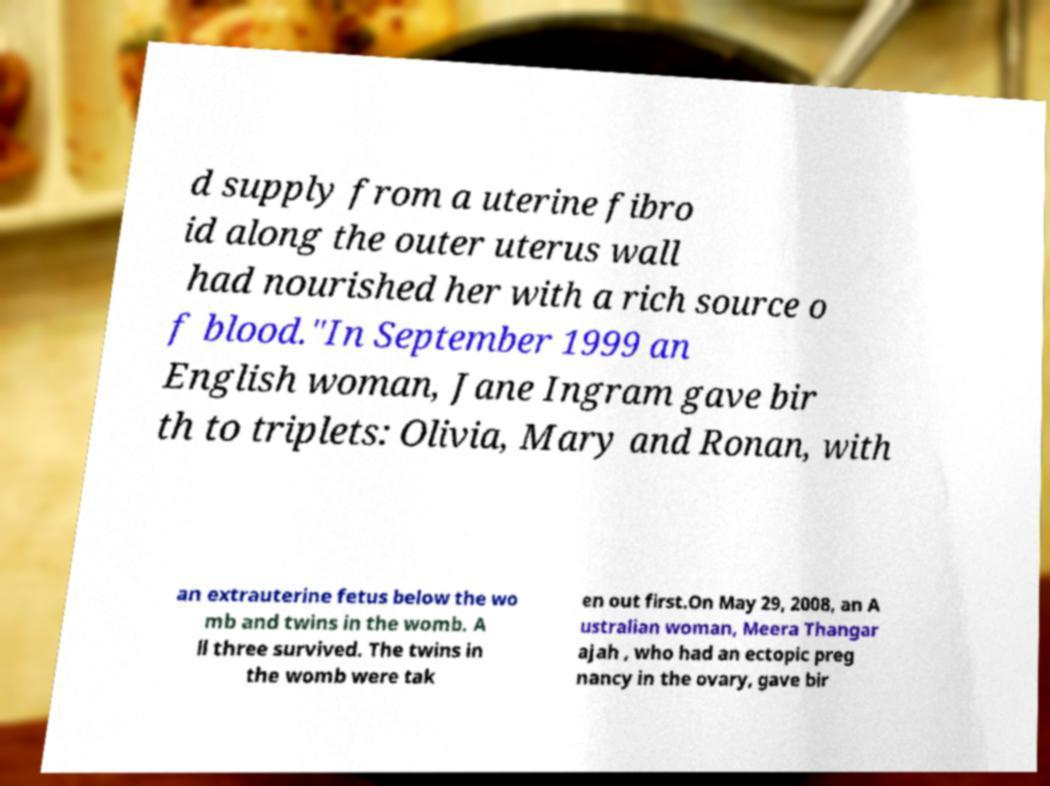Could you extract and type out the text from this image? d supply from a uterine fibro id along the outer uterus wall had nourished her with a rich source o f blood."In September 1999 an English woman, Jane Ingram gave bir th to triplets: Olivia, Mary and Ronan, with an extrauterine fetus below the wo mb and twins in the womb. A ll three survived. The twins in the womb were tak en out first.On May 29, 2008, an A ustralian woman, Meera Thangar ajah , who had an ectopic preg nancy in the ovary, gave bir 